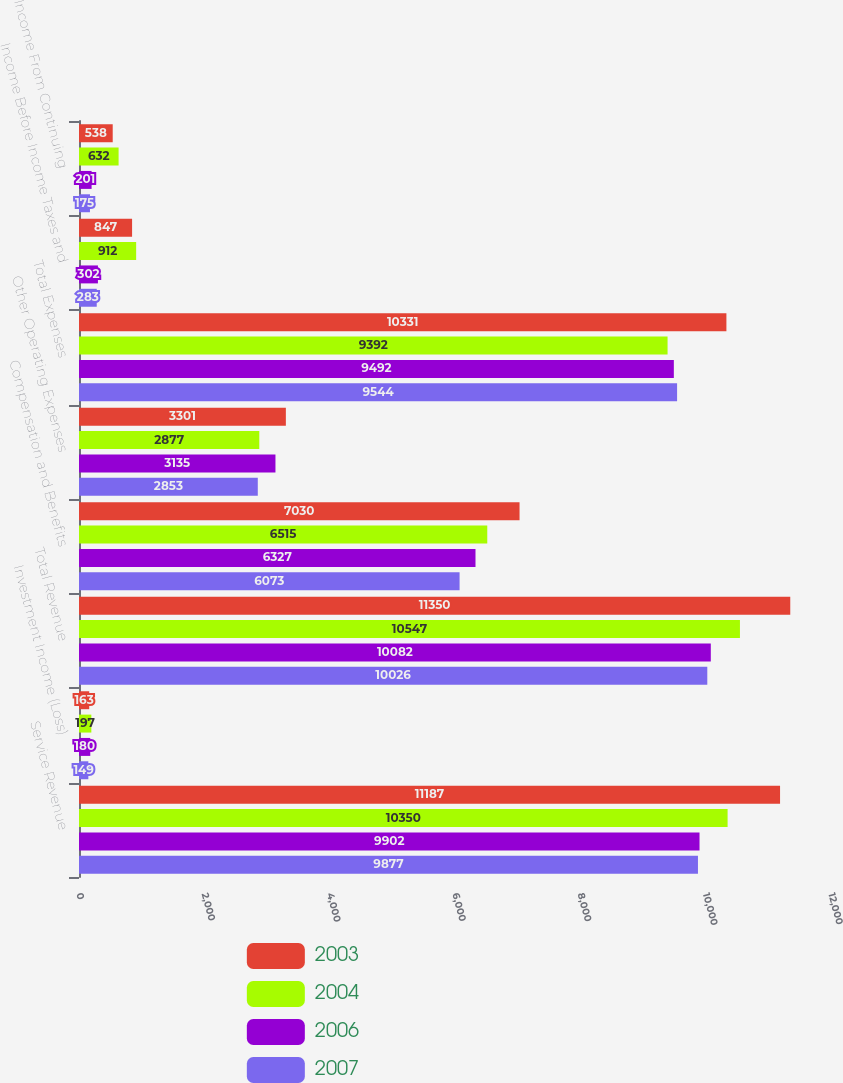Convert chart. <chart><loc_0><loc_0><loc_500><loc_500><stacked_bar_chart><ecel><fcel>Service Revenue<fcel>Investment Income (Loss)<fcel>Total Revenue<fcel>Compensation and Benefits<fcel>Other Operating Expenses<fcel>Total Expenses<fcel>Income Before Income Taxes and<fcel>Income From Continuing<nl><fcel>2003<fcel>11187<fcel>163<fcel>11350<fcel>7030<fcel>3301<fcel>10331<fcel>847<fcel>538<nl><fcel>2004<fcel>10350<fcel>197<fcel>10547<fcel>6515<fcel>2877<fcel>9392<fcel>912<fcel>632<nl><fcel>2006<fcel>9902<fcel>180<fcel>10082<fcel>6327<fcel>3135<fcel>9492<fcel>302<fcel>201<nl><fcel>2007<fcel>9877<fcel>149<fcel>10026<fcel>6073<fcel>2853<fcel>9544<fcel>283<fcel>175<nl></chart> 